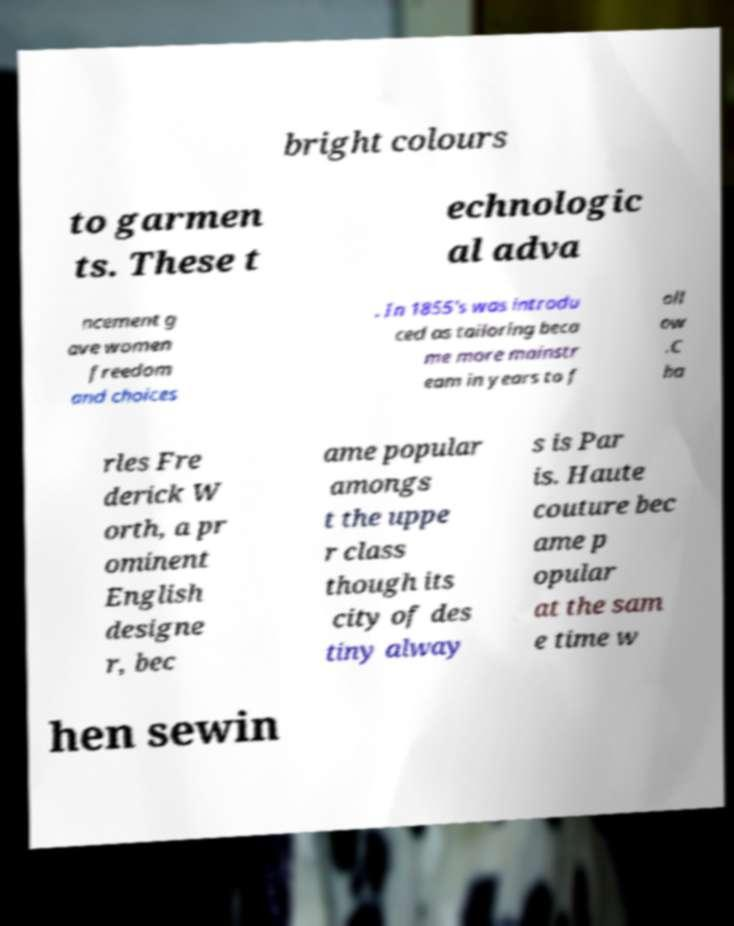Please read and relay the text visible in this image. What does it say? bright colours to garmen ts. These t echnologic al adva ncement g ave women freedom and choices . In 1855's was introdu ced as tailoring beca me more mainstr eam in years to f oll ow .C ha rles Fre derick W orth, a pr ominent English designe r, bec ame popular amongs t the uppe r class though its city of des tiny alway s is Par is. Haute couture bec ame p opular at the sam e time w hen sewin 